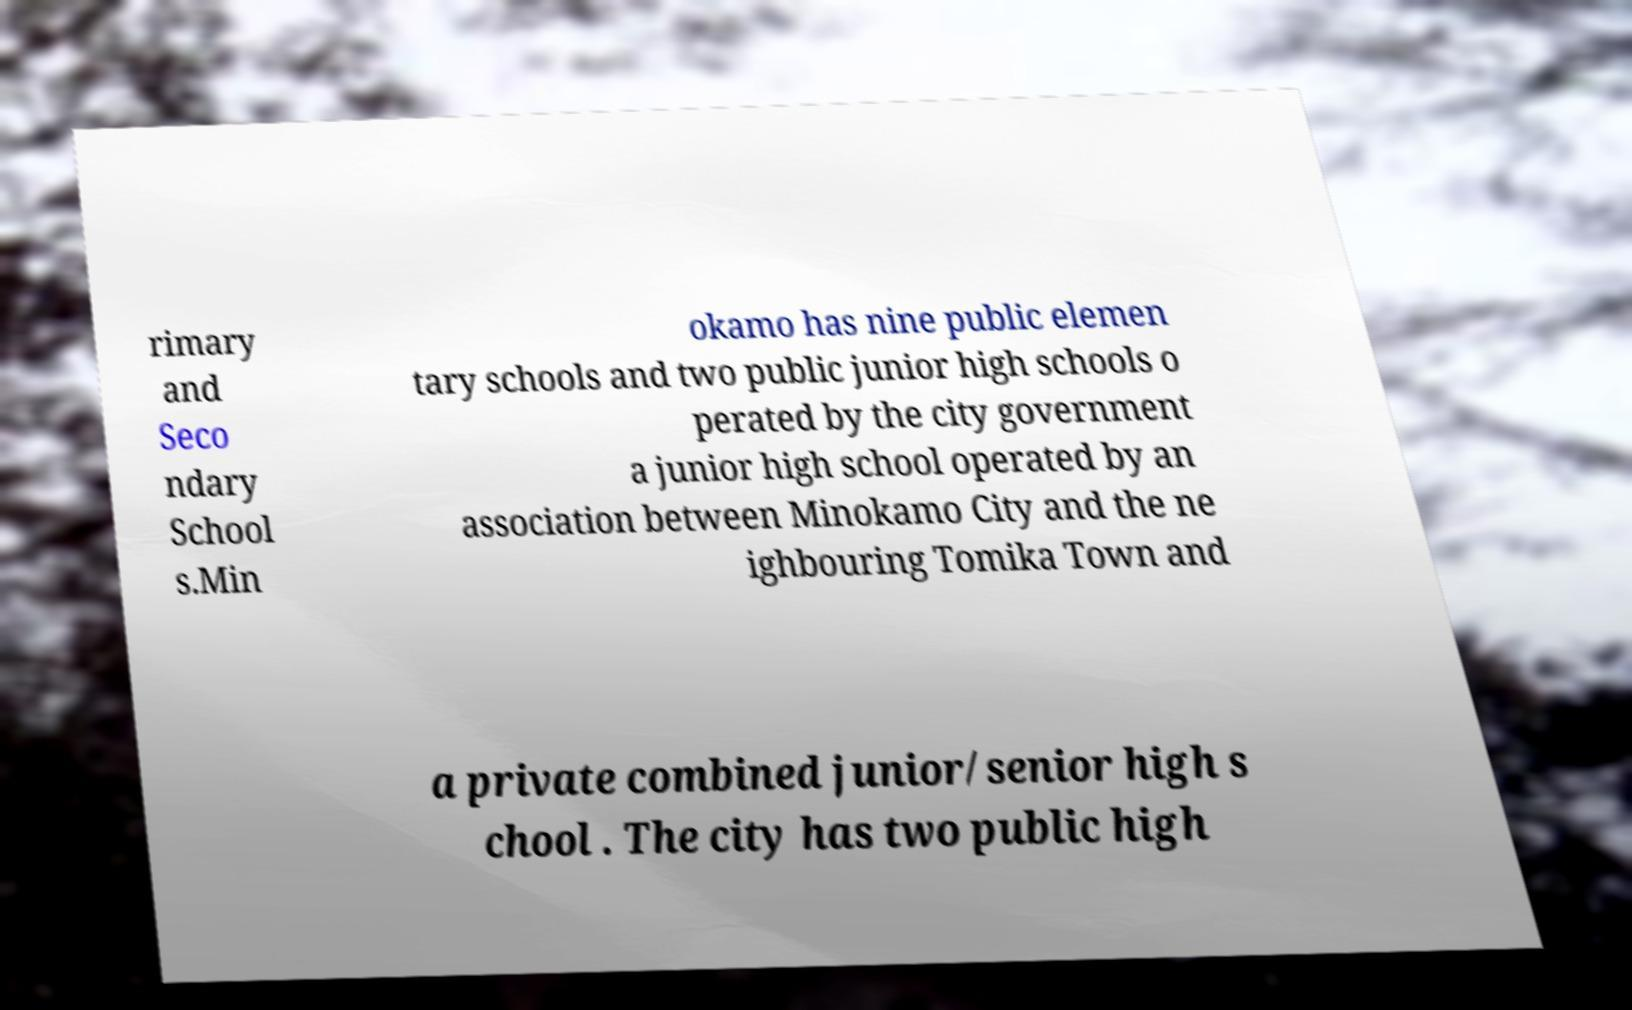What messages or text are displayed in this image? I need them in a readable, typed format. rimary and Seco ndary School s.Min okamo has nine public elemen tary schools and two public junior high schools o perated by the city government a junior high school operated by an association between Minokamo City and the ne ighbouring Tomika Town and a private combined junior/senior high s chool . The city has two public high 